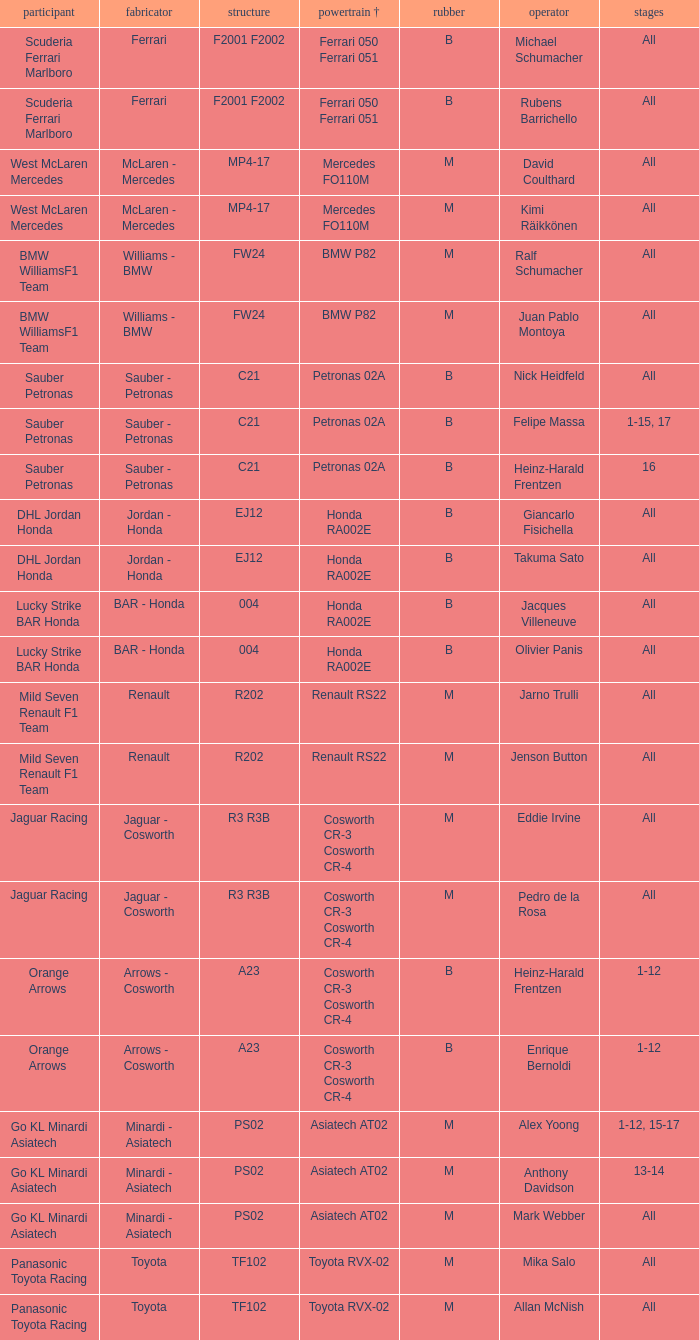What is the chassis when the tyre is b, the engine is ferrari 050 ferrari 051 and the driver is rubens barrichello? F2001 F2002. Help me parse the entirety of this table. {'header': ['participant', 'fabricator', 'structure', 'powertrain †', 'rubber', 'operator', 'stages'], 'rows': [['Scuderia Ferrari Marlboro', 'Ferrari', 'F2001 F2002', 'Ferrari 050 Ferrari 051', 'B', 'Michael Schumacher', 'All'], ['Scuderia Ferrari Marlboro', 'Ferrari', 'F2001 F2002', 'Ferrari 050 Ferrari 051', 'B', 'Rubens Barrichello', 'All'], ['West McLaren Mercedes', 'McLaren - Mercedes', 'MP4-17', 'Mercedes FO110M', 'M', 'David Coulthard', 'All'], ['West McLaren Mercedes', 'McLaren - Mercedes', 'MP4-17', 'Mercedes FO110M', 'M', 'Kimi Räikkönen', 'All'], ['BMW WilliamsF1 Team', 'Williams - BMW', 'FW24', 'BMW P82', 'M', 'Ralf Schumacher', 'All'], ['BMW WilliamsF1 Team', 'Williams - BMW', 'FW24', 'BMW P82', 'M', 'Juan Pablo Montoya', 'All'], ['Sauber Petronas', 'Sauber - Petronas', 'C21', 'Petronas 02A', 'B', 'Nick Heidfeld', 'All'], ['Sauber Petronas', 'Sauber - Petronas', 'C21', 'Petronas 02A', 'B', 'Felipe Massa', '1-15, 17'], ['Sauber Petronas', 'Sauber - Petronas', 'C21', 'Petronas 02A', 'B', 'Heinz-Harald Frentzen', '16'], ['DHL Jordan Honda', 'Jordan - Honda', 'EJ12', 'Honda RA002E', 'B', 'Giancarlo Fisichella', 'All'], ['DHL Jordan Honda', 'Jordan - Honda', 'EJ12', 'Honda RA002E', 'B', 'Takuma Sato', 'All'], ['Lucky Strike BAR Honda', 'BAR - Honda', '004', 'Honda RA002E', 'B', 'Jacques Villeneuve', 'All'], ['Lucky Strike BAR Honda', 'BAR - Honda', '004', 'Honda RA002E', 'B', 'Olivier Panis', 'All'], ['Mild Seven Renault F1 Team', 'Renault', 'R202', 'Renault RS22', 'M', 'Jarno Trulli', 'All'], ['Mild Seven Renault F1 Team', 'Renault', 'R202', 'Renault RS22', 'M', 'Jenson Button', 'All'], ['Jaguar Racing', 'Jaguar - Cosworth', 'R3 R3B', 'Cosworth CR-3 Cosworth CR-4', 'M', 'Eddie Irvine', 'All'], ['Jaguar Racing', 'Jaguar - Cosworth', 'R3 R3B', 'Cosworth CR-3 Cosworth CR-4', 'M', 'Pedro de la Rosa', 'All'], ['Orange Arrows', 'Arrows - Cosworth', 'A23', 'Cosworth CR-3 Cosworth CR-4', 'B', 'Heinz-Harald Frentzen', '1-12'], ['Orange Arrows', 'Arrows - Cosworth', 'A23', 'Cosworth CR-3 Cosworth CR-4', 'B', 'Enrique Bernoldi', '1-12'], ['Go KL Minardi Asiatech', 'Minardi - Asiatech', 'PS02', 'Asiatech AT02', 'M', 'Alex Yoong', '1-12, 15-17'], ['Go KL Minardi Asiatech', 'Minardi - Asiatech', 'PS02', 'Asiatech AT02', 'M', 'Anthony Davidson', '13-14'], ['Go KL Minardi Asiatech', 'Minardi - Asiatech', 'PS02', 'Asiatech AT02', 'M', 'Mark Webber', 'All'], ['Panasonic Toyota Racing', 'Toyota', 'TF102', 'Toyota RVX-02', 'M', 'Mika Salo', 'All'], ['Panasonic Toyota Racing', 'Toyota', 'TF102', 'Toyota RVX-02', 'M', 'Allan McNish', 'All']]} 